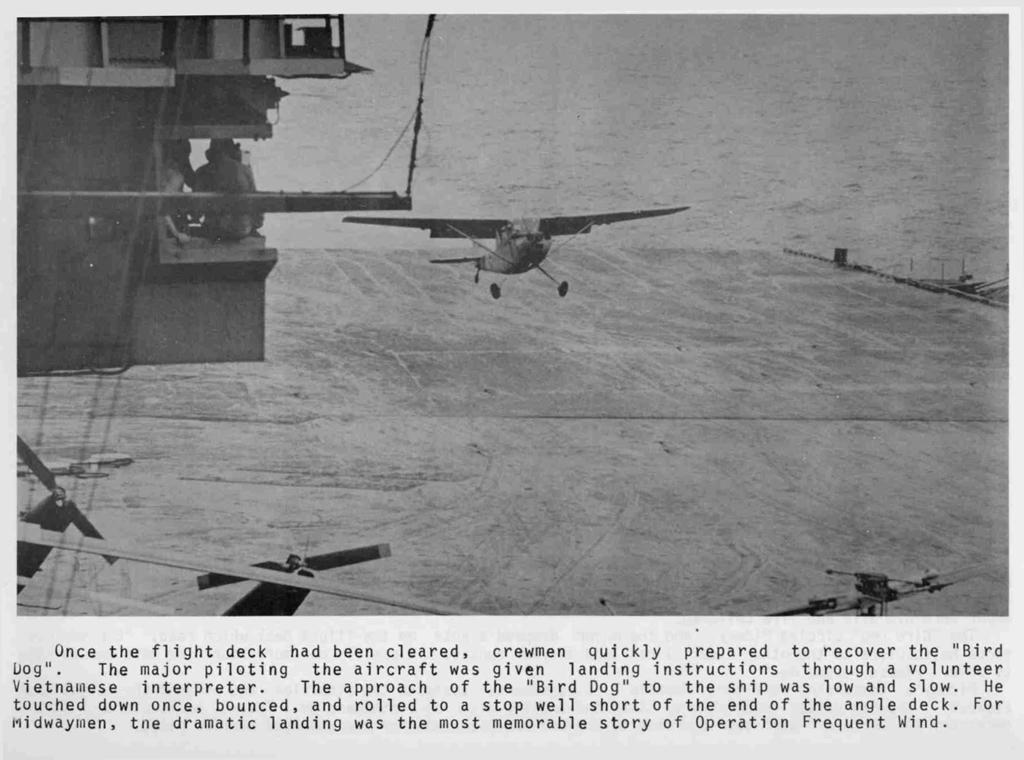What is depicted in the images in the picture? The pictures contain airplanes flying in the air. What else can be seen in the image besides the pictures? There is text in the image. What type of building is shown in the image? There is no building present in the image; it only contains pictures of airplanes and text. 